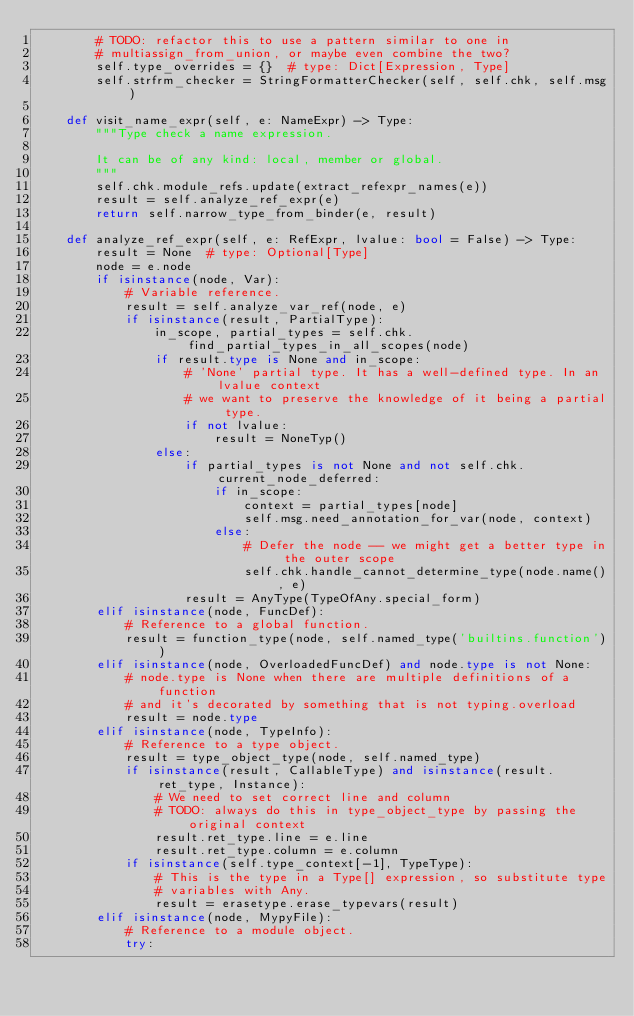Convert code to text. <code><loc_0><loc_0><loc_500><loc_500><_Python_>        # TODO: refactor this to use a pattern similar to one in
        # multiassign_from_union, or maybe even combine the two?
        self.type_overrides = {}  # type: Dict[Expression, Type]
        self.strfrm_checker = StringFormatterChecker(self, self.chk, self.msg)

    def visit_name_expr(self, e: NameExpr) -> Type:
        """Type check a name expression.

        It can be of any kind: local, member or global.
        """
        self.chk.module_refs.update(extract_refexpr_names(e))
        result = self.analyze_ref_expr(e)
        return self.narrow_type_from_binder(e, result)

    def analyze_ref_expr(self, e: RefExpr, lvalue: bool = False) -> Type:
        result = None  # type: Optional[Type]
        node = e.node
        if isinstance(node, Var):
            # Variable reference.
            result = self.analyze_var_ref(node, e)
            if isinstance(result, PartialType):
                in_scope, partial_types = self.chk.find_partial_types_in_all_scopes(node)
                if result.type is None and in_scope:
                    # 'None' partial type. It has a well-defined type. In an lvalue context
                    # we want to preserve the knowledge of it being a partial type.
                    if not lvalue:
                        result = NoneTyp()
                else:
                    if partial_types is not None and not self.chk.current_node_deferred:
                        if in_scope:
                            context = partial_types[node]
                            self.msg.need_annotation_for_var(node, context)
                        else:
                            # Defer the node -- we might get a better type in the outer scope
                            self.chk.handle_cannot_determine_type(node.name(), e)
                    result = AnyType(TypeOfAny.special_form)
        elif isinstance(node, FuncDef):
            # Reference to a global function.
            result = function_type(node, self.named_type('builtins.function'))
        elif isinstance(node, OverloadedFuncDef) and node.type is not None:
            # node.type is None when there are multiple definitions of a function
            # and it's decorated by something that is not typing.overload
            result = node.type
        elif isinstance(node, TypeInfo):
            # Reference to a type object.
            result = type_object_type(node, self.named_type)
            if isinstance(result, CallableType) and isinstance(result.ret_type, Instance):
                # We need to set correct line and column
                # TODO: always do this in type_object_type by passing the original context
                result.ret_type.line = e.line
                result.ret_type.column = e.column
            if isinstance(self.type_context[-1], TypeType):
                # This is the type in a Type[] expression, so substitute type
                # variables with Any.
                result = erasetype.erase_typevars(result)
        elif isinstance(node, MypyFile):
            # Reference to a module object.
            try:</code> 